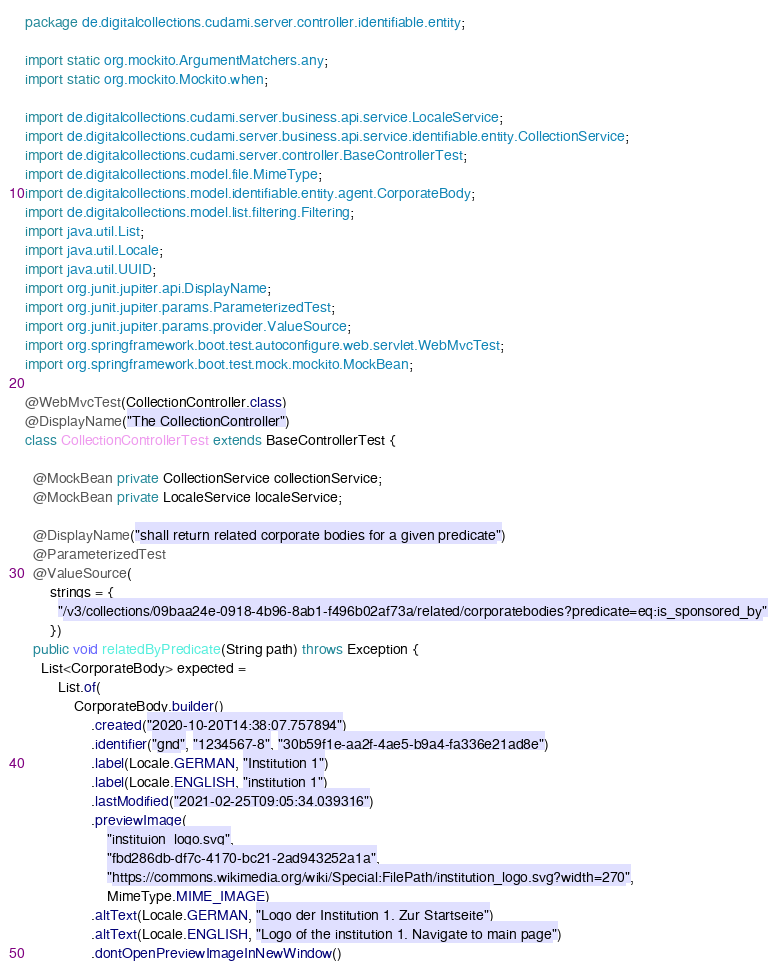<code> <loc_0><loc_0><loc_500><loc_500><_Java_>package de.digitalcollections.cudami.server.controller.identifiable.entity;

import static org.mockito.ArgumentMatchers.any;
import static org.mockito.Mockito.when;

import de.digitalcollections.cudami.server.business.api.service.LocaleService;
import de.digitalcollections.cudami.server.business.api.service.identifiable.entity.CollectionService;
import de.digitalcollections.cudami.server.controller.BaseControllerTest;
import de.digitalcollections.model.file.MimeType;
import de.digitalcollections.model.identifiable.entity.agent.CorporateBody;
import de.digitalcollections.model.list.filtering.Filtering;
import java.util.List;
import java.util.Locale;
import java.util.UUID;
import org.junit.jupiter.api.DisplayName;
import org.junit.jupiter.params.ParameterizedTest;
import org.junit.jupiter.params.provider.ValueSource;
import org.springframework.boot.test.autoconfigure.web.servlet.WebMvcTest;
import org.springframework.boot.test.mock.mockito.MockBean;

@WebMvcTest(CollectionController.class)
@DisplayName("The CollectionController")
class CollectionControllerTest extends BaseControllerTest {

  @MockBean private CollectionService collectionService;
  @MockBean private LocaleService localeService;

  @DisplayName("shall return related corporate bodies for a given predicate")
  @ParameterizedTest
  @ValueSource(
      strings = {
        "/v3/collections/09baa24e-0918-4b96-8ab1-f496b02af73a/related/corporatebodies?predicate=eq:is_sponsored_by"
      })
  public void relatedByPredicate(String path) throws Exception {
    List<CorporateBody> expected =
        List.of(
            CorporateBody.builder()
                .created("2020-10-20T14:38:07.757894")
                .identifier("gnd", "1234567-8", "30b59f1e-aa2f-4ae5-b9a4-fa336e21ad8e")
                .label(Locale.GERMAN, "Institution 1")
                .label(Locale.ENGLISH, "institution 1")
                .lastModified("2021-02-25T09:05:34.039316")
                .previewImage(
                    "instituion_logo.svg",
                    "fbd286db-df7c-4170-bc21-2ad943252a1a",
                    "https://commons.wikimedia.org/wiki/Special:FilePath/institution_logo.svg?width=270",
                    MimeType.MIME_IMAGE)
                .altText(Locale.GERMAN, "Logo der Institution 1. Zur Startseite")
                .altText(Locale.ENGLISH, "Logo of the institution 1. Navigate to main page")
                .dontOpenPreviewImageInNewWindow()</code> 